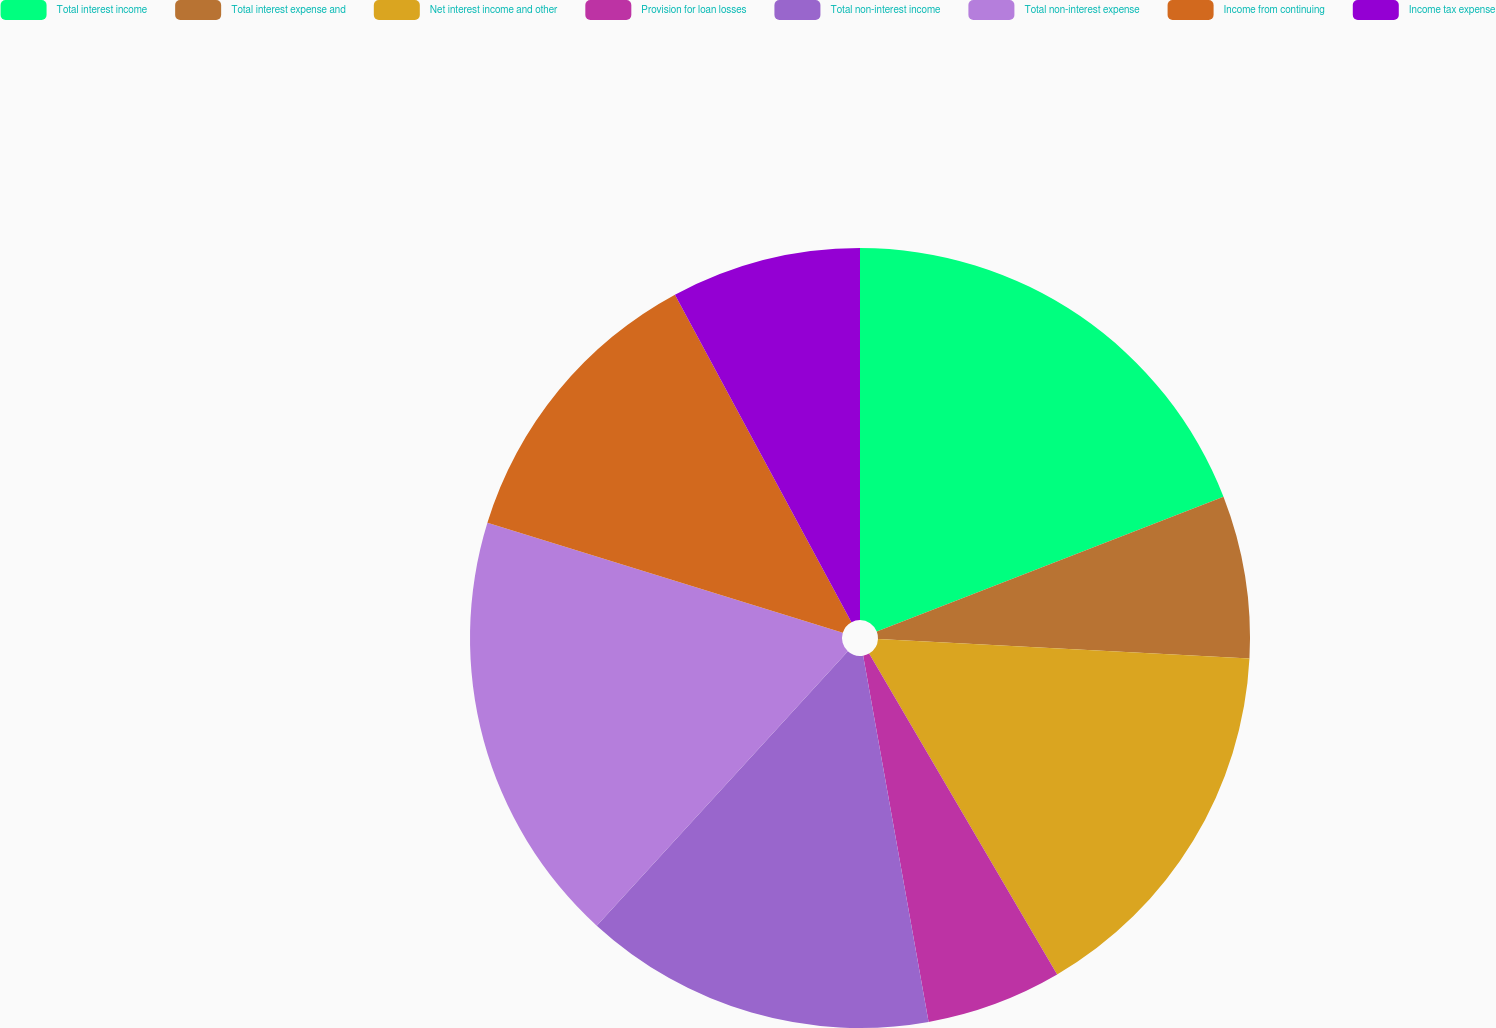<chart> <loc_0><loc_0><loc_500><loc_500><pie_chart><fcel>Total interest income<fcel>Total interest expense and<fcel>Net interest income and other<fcel>Provision for loan losses<fcel>Total non-interest income<fcel>Total non-interest expense<fcel>Income from continuing<fcel>Income tax expense<nl><fcel>19.1%<fcel>6.74%<fcel>15.73%<fcel>5.62%<fcel>14.61%<fcel>17.98%<fcel>12.36%<fcel>7.87%<nl></chart> 